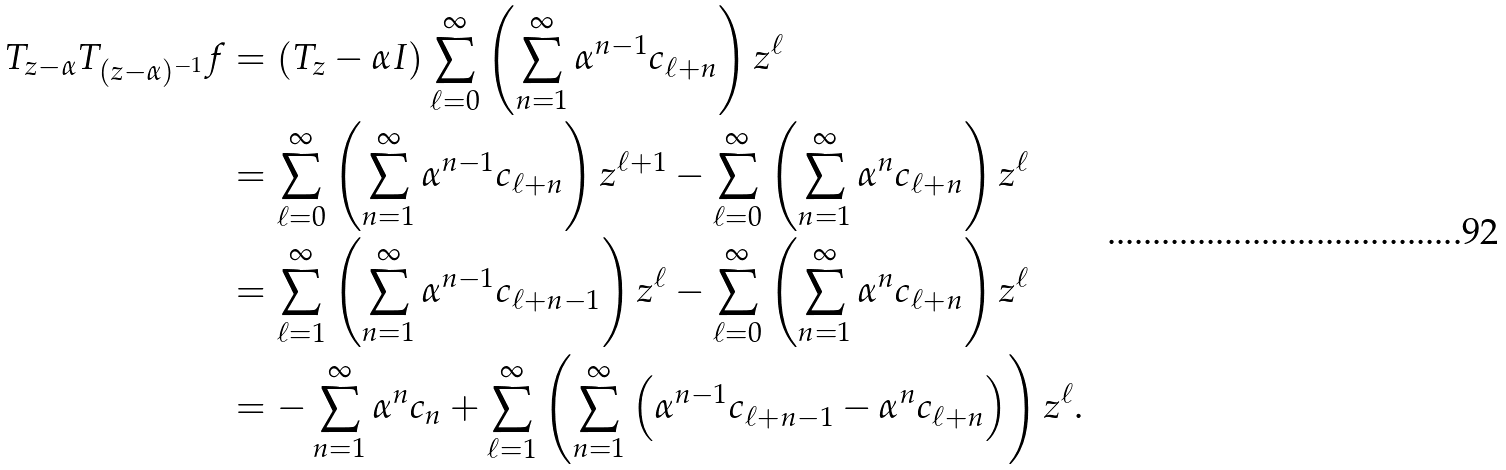Convert formula to latex. <formula><loc_0><loc_0><loc_500><loc_500>T _ { z - \alpha } T _ { ( z - \alpha ) ^ { - 1 } } f & = \left ( T _ { z } - \alpha I \right ) \sum _ { \ell = 0 } ^ { \infty } \left ( \sum _ { n = 1 } ^ { \infty } \alpha ^ { n - 1 } c _ { \ell + n } \right ) z ^ { \ell } \\ & = \sum _ { \ell = 0 } ^ { \infty } \left ( \sum _ { n = 1 } ^ { \infty } \alpha ^ { n - 1 } c _ { \ell + n } \right ) z ^ { \ell + 1 } - \sum _ { \ell = 0 } ^ { \infty } \left ( \sum _ { n = 1 } ^ { \infty } \alpha ^ { n } c _ { \ell + n } \right ) z ^ { \ell } \\ & = \sum _ { \ell = 1 } ^ { \infty } \left ( \sum _ { n = 1 } ^ { \infty } \alpha ^ { n - 1 } c _ { \ell + n - 1 } \right ) z ^ { \ell } - \sum _ { \ell = 0 } ^ { \infty } \left ( \sum _ { n = 1 } ^ { \infty } \alpha ^ { n } c _ { \ell + n } \right ) z ^ { \ell } \\ & = - \sum _ { n = 1 } ^ { \infty } \alpha ^ { n } c _ { n } + \sum _ { \ell = 1 } ^ { \infty } \left ( \sum _ { n = 1 } ^ { \infty } \left ( \alpha ^ { n - 1 } c _ { \ell + n - 1 } - \alpha ^ { n } c _ { \ell + n } \right ) \right ) z ^ { \ell } .</formula> 